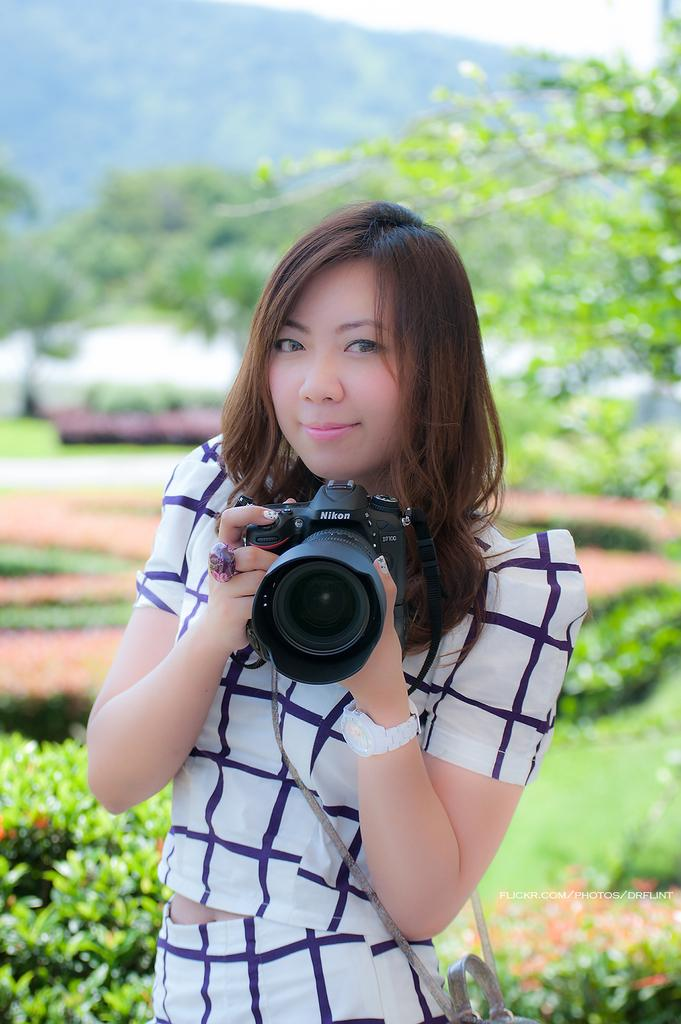Who is the main subject in the image? There is a woman in the image. What is the woman holding in her hands? The woman is holding a camera in her hands. What can be seen in the background of the image? There are trees, plants, and the sky visible in the background of the image. Where is the dock located in the image? There is no dock present in the image. What type of system is being used by the woman to take pictures? The provided facts do not mention any specific system being used by the woman to take pictures; she is simply holding a camera. 